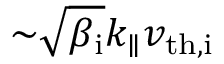Convert formula to latex. <formula><loc_0><loc_0><loc_500><loc_500>{ \sim } \sqrt { \beta _ { i } } k _ { \| } v _ { t h , i }</formula> 